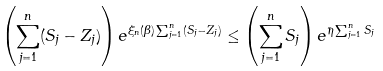<formula> <loc_0><loc_0><loc_500><loc_500>\left ( \sum _ { j = 1 } ^ { n } ( S _ { j } - Z _ { j } ) \right ) e ^ { \xi _ { n } ( \beta ) \sum _ { j = 1 } ^ { n } ( S _ { j } - Z _ { j } ) } \leq \left ( \sum _ { j = 1 } ^ { n } S _ { j } \right ) e ^ { \bar { \eta } \sum _ { j = 1 } ^ { n } S _ { j } }</formula> 